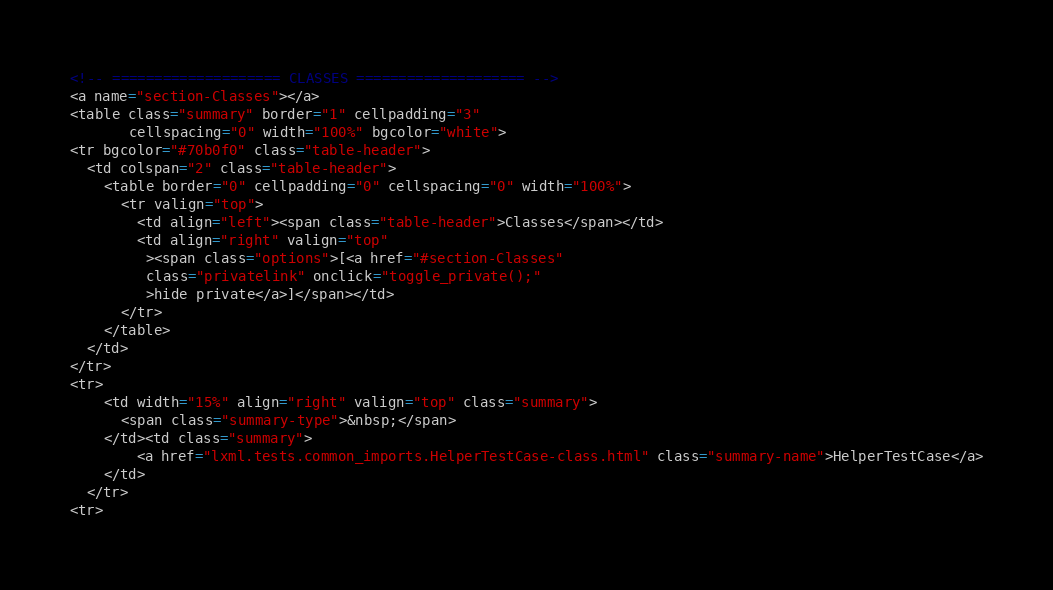Convert code to text. <code><loc_0><loc_0><loc_500><loc_500><_HTML_><!-- ==================== CLASSES ==================== -->
<a name="section-Classes"></a>
<table class="summary" border="1" cellpadding="3"
       cellspacing="0" width="100%" bgcolor="white">
<tr bgcolor="#70b0f0" class="table-header">
  <td colspan="2" class="table-header">
    <table border="0" cellpadding="0" cellspacing="0" width="100%">
      <tr valign="top">
        <td align="left"><span class="table-header">Classes</span></td>
        <td align="right" valign="top"
         ><span class="options">[<a href="#section-Classes"
         class="privatelink" onclick="toggle_private();"
         >hide private</a>]</span></td>
      </tr>
    </table>
  </td>
</tr>
<tr>
    <td width="15%" align="right" valign="top" class="summary">
      <span class="summary-type">&nbsp;</span>
    </td><td class="summary">
        <a href="lxml.tests.common_imports.HelperTestCase-class.html" class="summary-name">HelperTestCase</a>
    </td>
  </tr>
<tr></code> 